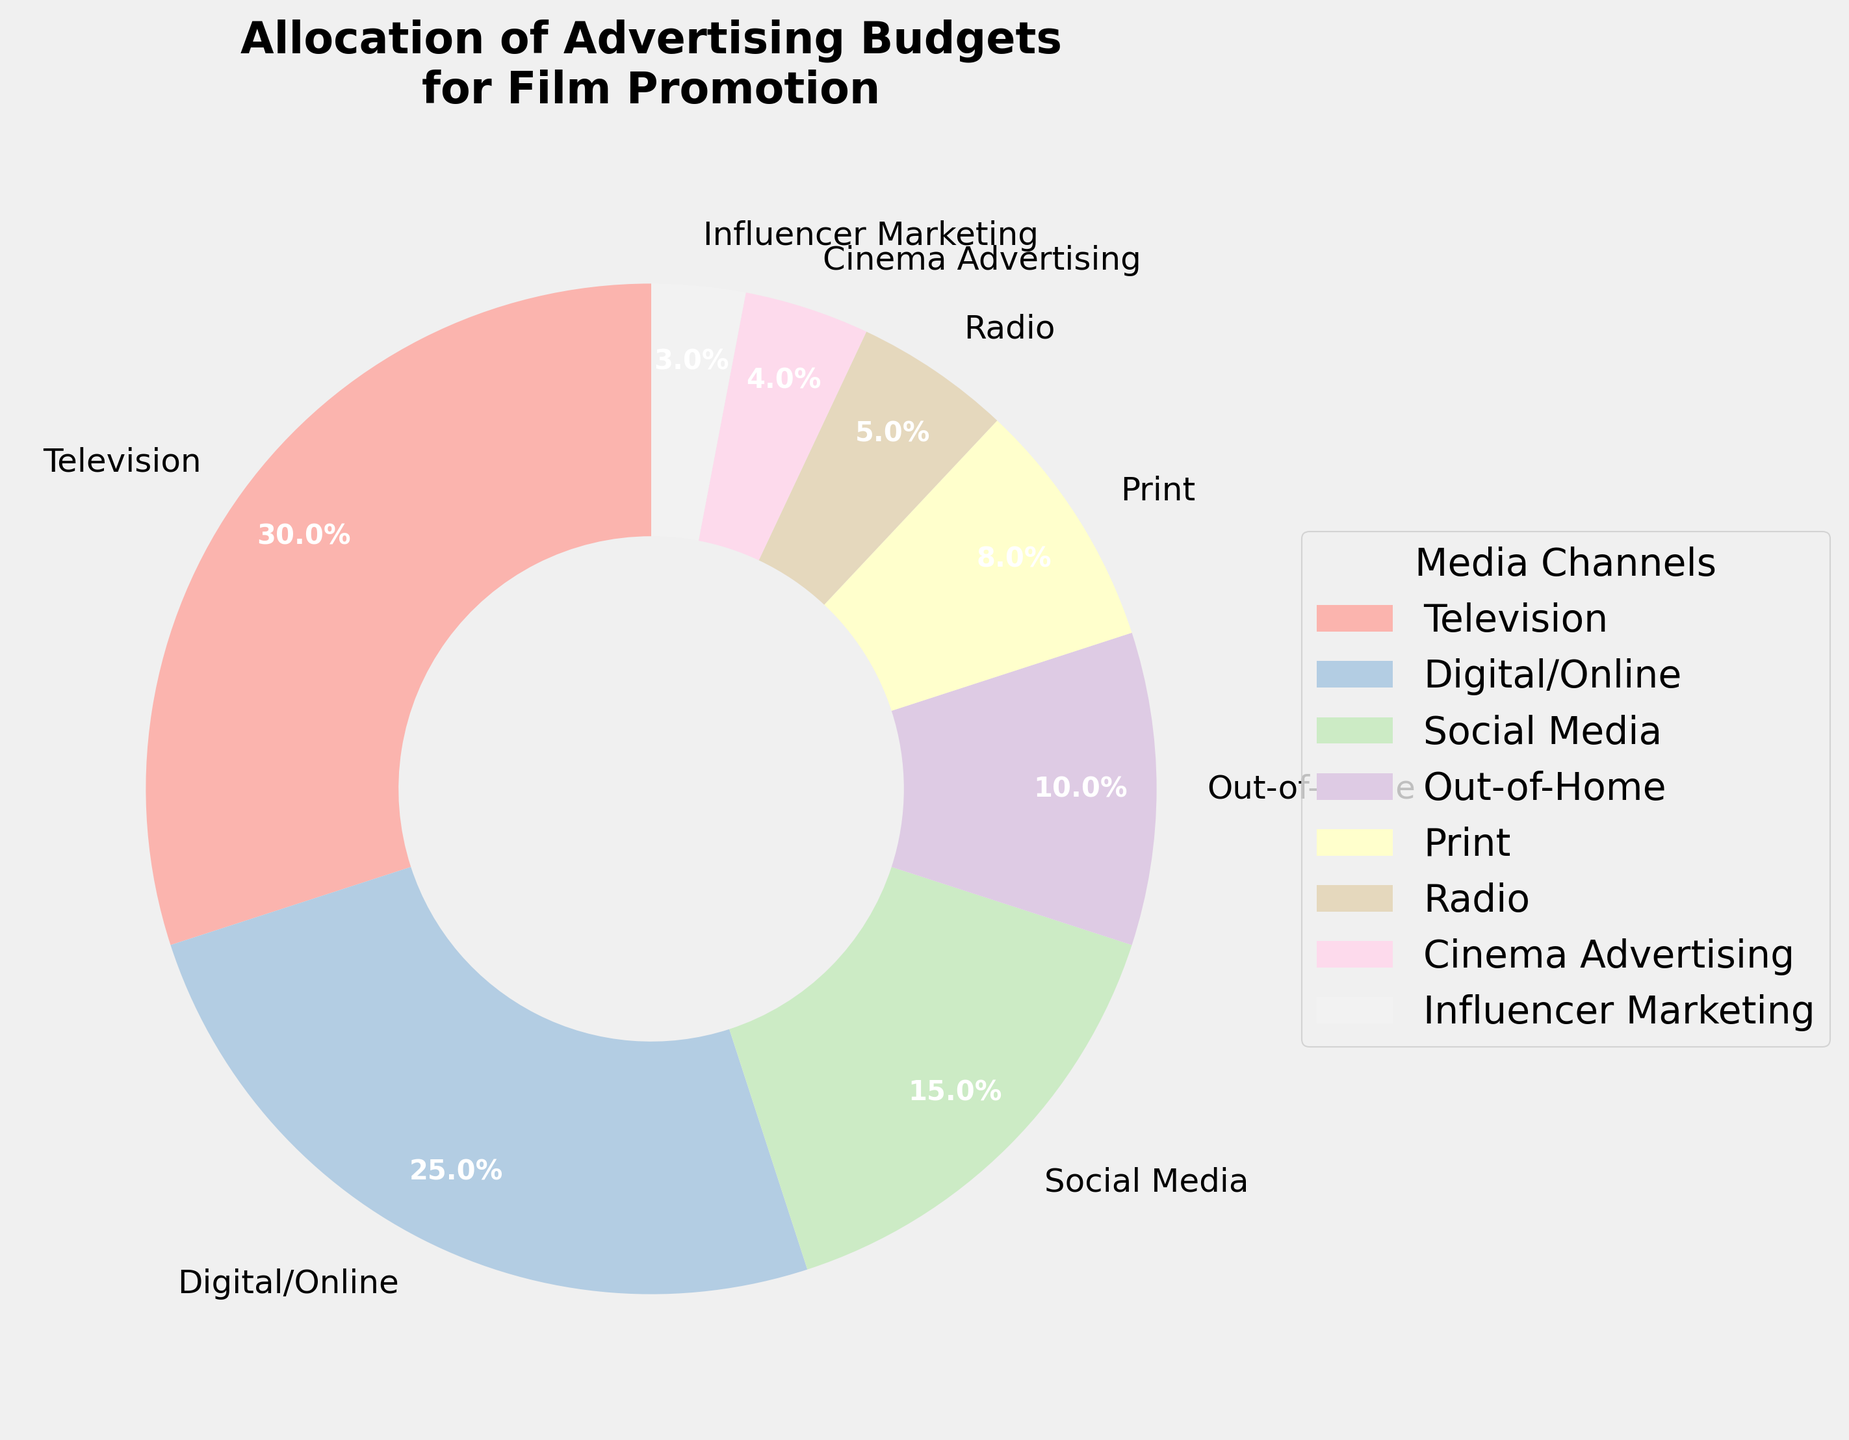What media channel gets the highest budget allocation? According to the pie chart, the media channel with the highest percentage wedge is Television, which is allocated 30% of the budget.
Answer: Television Which media channel has the smallest budget allocation, and what is the percentage allocated to it? The smallest wedge in the pie chart represents Influencer Marketing, which is allocated 3% of the budget.
Answer: Influencer Marketing, 3% How much more budget is allocated to Digital/Online compared to Radio? Digital/Online is allocated 25% of the budget and Radio is allocated 5%. The difference is calculated as 25% - 5% = 20%.
Answer: 20% What is the combined budget allocation for Print, Radio, and Cinema Advertising? The budget allocations for Print, Radio, and Cinema Advertising are 8%, 5%, and 4% respectively. Combined, this is 8% + 5% + 4% = 17%.
Answer: 17% Is the budget allocation for Social Media greater than that for Out-of-Home? By how much? According to the pie chart, Social Media is allocated 15% of the budget, whereas Out-of-Home is allocated 10%. The difference is 15% - 10% = 5%.
Answer: Yes, by 5% What is the total budget allocation for digital-focused channels (Digital/Online and Social Media)? Digital/Online and Social Media are allocated 25% and 15% of the budget respectively. The total is 25% + 15% = 40%.
Answer: 40% If you combine the budget allocations for Influencer Marketing and Cinema Advertising, how does it compare to the allocation for Radio? The sum of the allocations for Influencer Marketing and Cinema Advertising is 3% + 4% = 7%, which is greater than the allocation for Radio, which is 5%.
Answer: 7%, greater Which two media channels have the closest budget allocations, and what are those values? The channels with the closest budget allocations are Cinema Advertising and Influencer Marketing with 4% and 3% respectively.
Answer: Cinema Advertising: 4%, Influencer Marketing: 3% Among Radio, Print, and Out-of-Home, which channel has the highest budget allocation, and what is it? The pie chart shows Print with 8%, Radio with 5%, and Out-of-Home with 10%. Out-of-Home has the highest allocation among the three.
Answer: Out-of-Home, 10% 